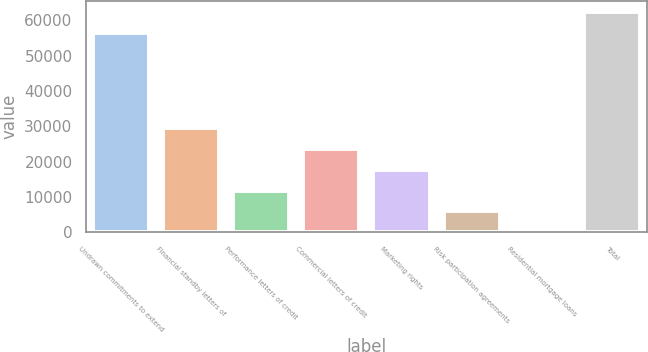Convert chart to OTSL. <chart><loc_0><loc_0><loc_500><loc_500><bar_chart><fcel>Undrawn commitments to extend<fcel>Financial standby letters of<fcel>Performance letters of credit<fcel>Commercial letters of credit<fcel>Marketing rights<fcel>Risk participation agreements<fcel>Residential mortgage loans<fcel>Total<nl><fcel>56524<fcel>29378<fcel>11757.2<fcel>23504.4<fcel>17630.8<fcel>5883.6<fcel>10<fcel>62397.6<nl></chart> 